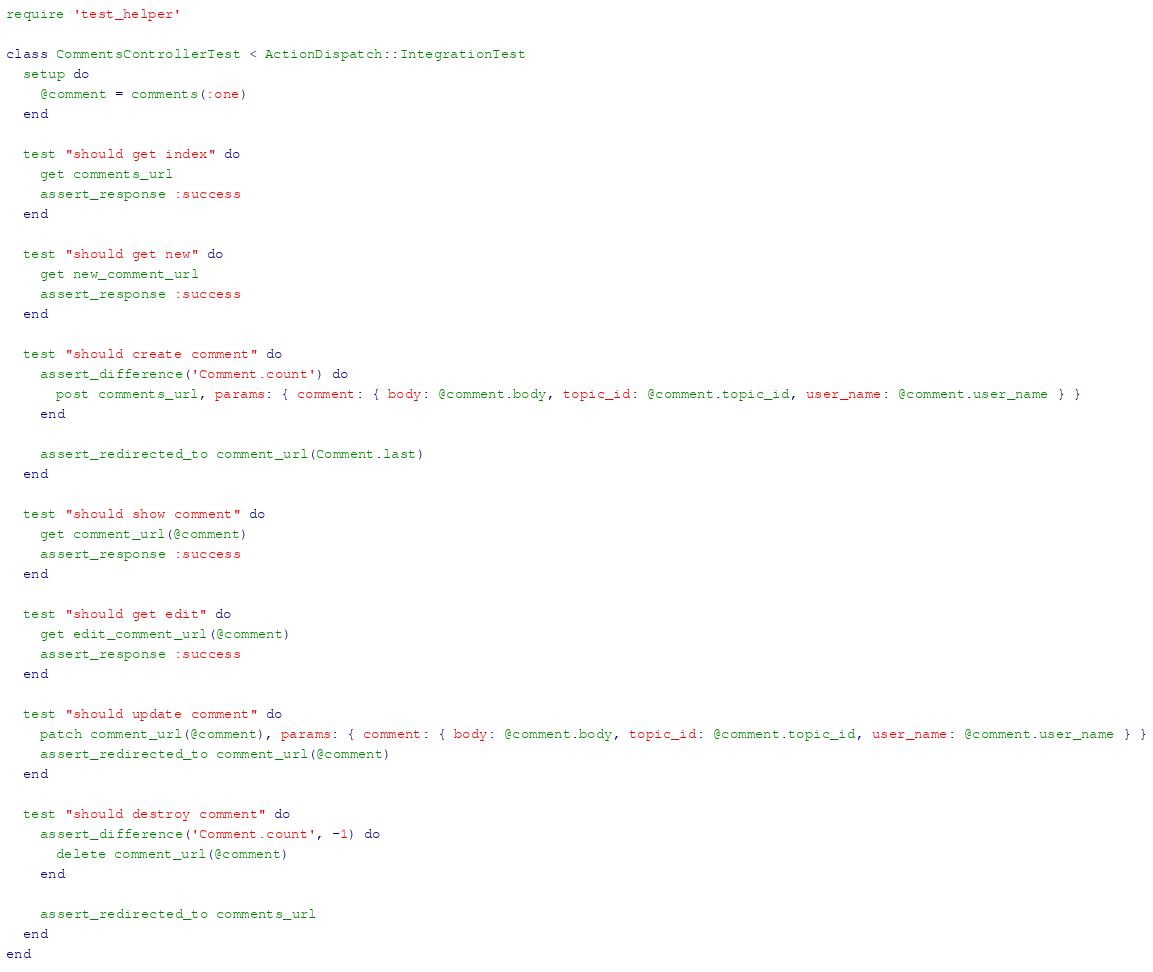Convert code to text. <code><loc_0><loc_0><loc_500><loc_500><_Ruby_>require 'test_helper'

class CommentsControllerTest < ActionDispatch::IntegrationTest
  setup do
    @comment = comments(:one)
  end

  test "should get index" do
    get comments_url
    assert_response :success
  end

  test "should get new" do
    get new_comment_url
    assert_response :success
  end

  test "should create comment" do
    assert_difference('Comment.count') do
      post comments_url, params: { comment: { body: @comment.body, topic_id: @comment.topic_id, user_name: @comment.user_name } }
    end

    assert_redirected_to comment_url(Comment.last)
  end

  test "should show comment" do
    get comment_url(@comment)
    assert_response :success
  end

  test "should get edit" do
    get edit_comment_url(@comment)
    assert_response :success
  end

  test "should update comment" do
    patch comment_url(@comment), params: { comment: { body: @comment.body, topic_id: @comment.topic_id, user_name: @comment.user_name } }
    assert_redirected_to comment_url(@comment)
  end

  test "should destroy comment" do
    assert_difference('Comment.count', -1) do
      delete comment_url(@comment)
    end

    assert_redirected_to comments_url
  end
end
</code> 